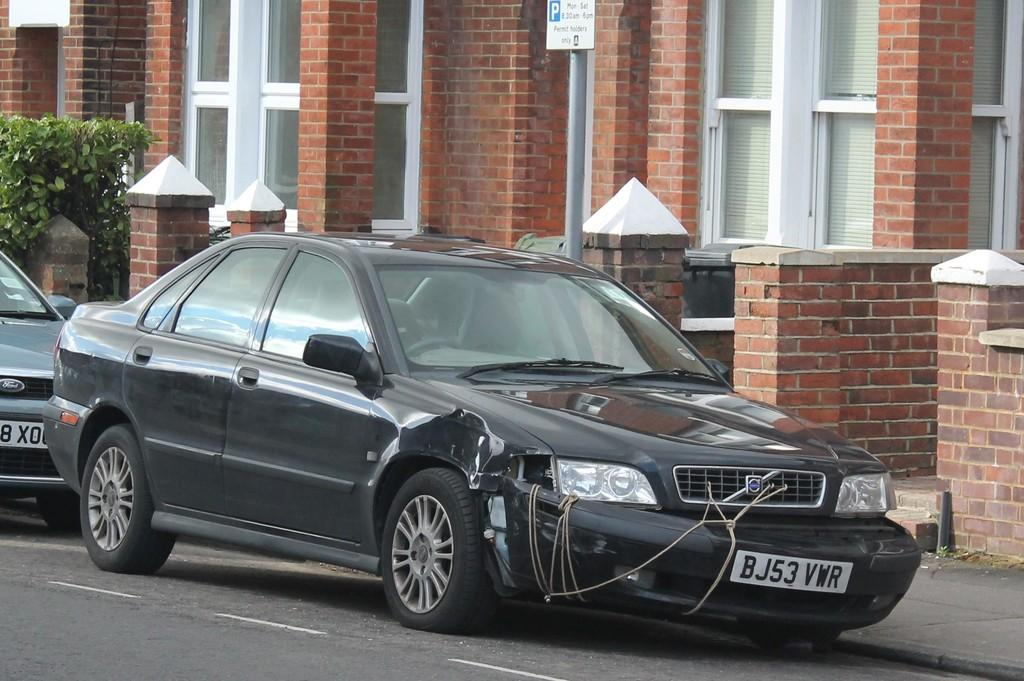<image>
Provide a brief description of the given image. Black car with a plate which says BJ53VMR. 